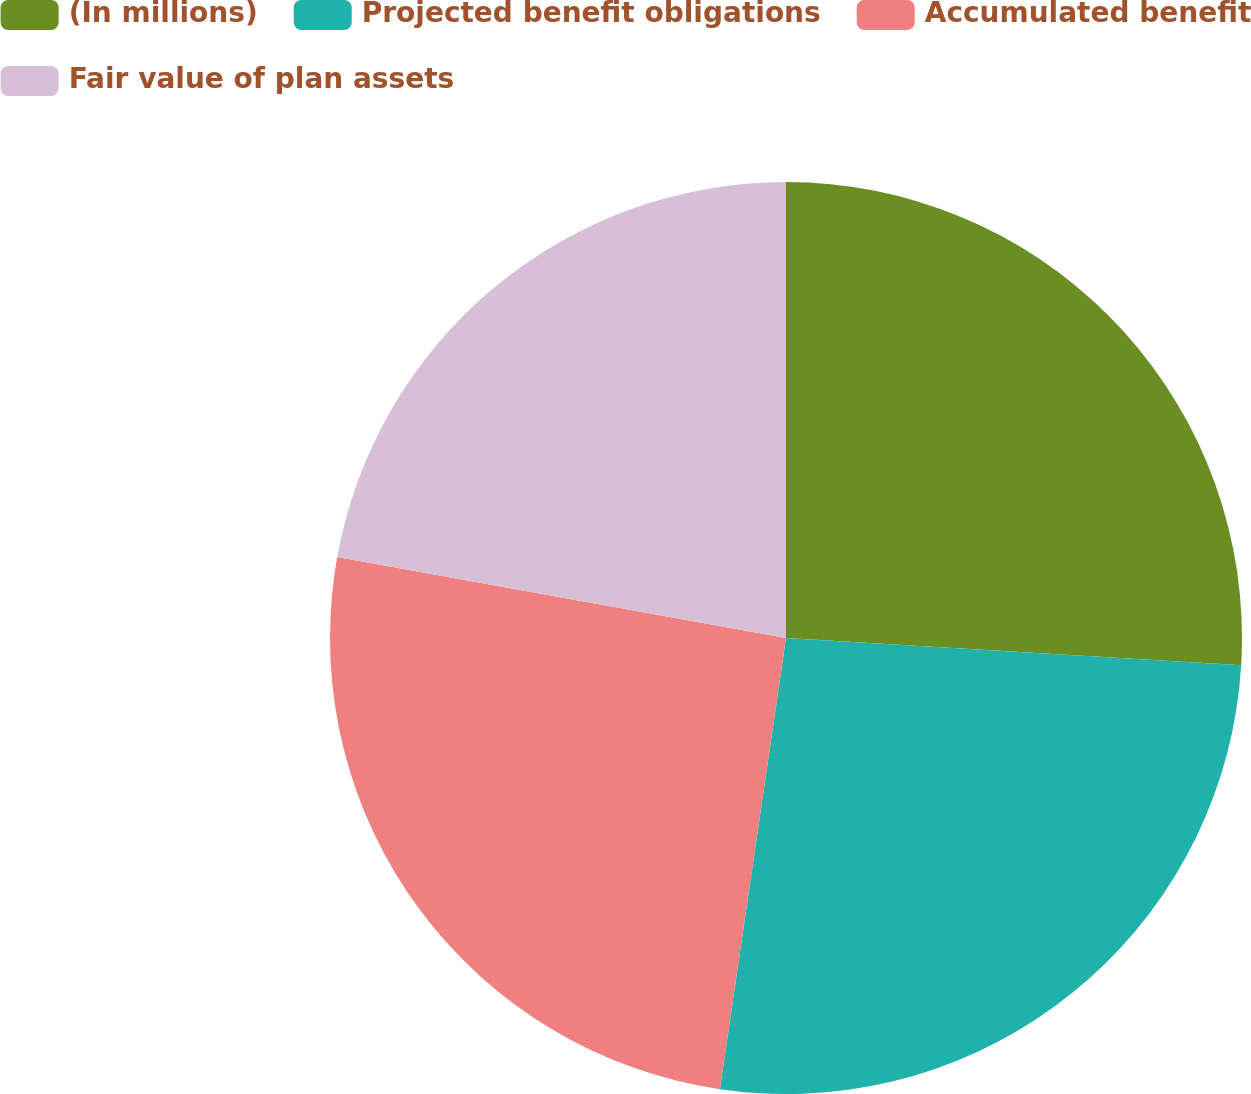Convert chart. <chart><loc_0><loc_0><loc_500><loc_500><pie_chart><fcel>(In millions)<fcel>Projected benefit obligations<fcel>Accumulated benefit<fcel>Fair value of plan assets<nl><fcel>25.95%<fcel>26.37%<fcel>25.53%<fcel>22.16%<nl></chart> 